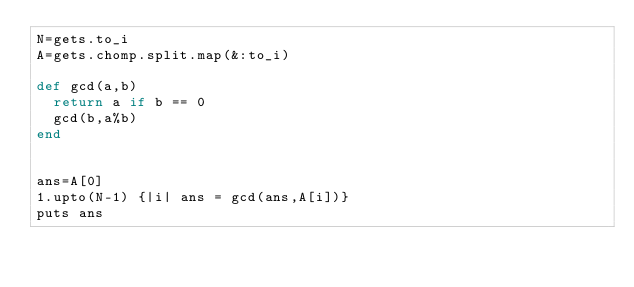Convert code to text. <code><loc_0><loc_0><loc_500><loc_500><_Ruby_>N=gets.to_i
A=gets.chomp.split.map(&:to_i)

def gcd(a,b)
  return a if b == 0
  gcd(b,a%b)
end


ans=A[0]
1.upto(N-1) {|i| ans = gcd(ans,A[i])}
puts ans</code> 